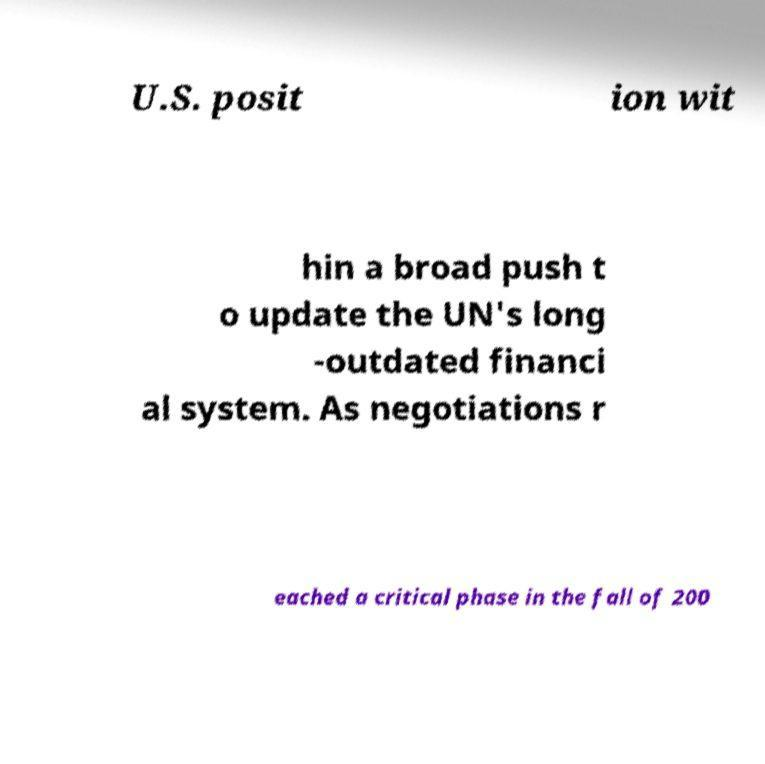For documentation purposes, I need the text within this image transcribed. Could you provide that? U.S. posit ion wit hin a broad push t o update the UN's long -outdated financi al system. As negotiations r eached a critical phase in the fall of 200 